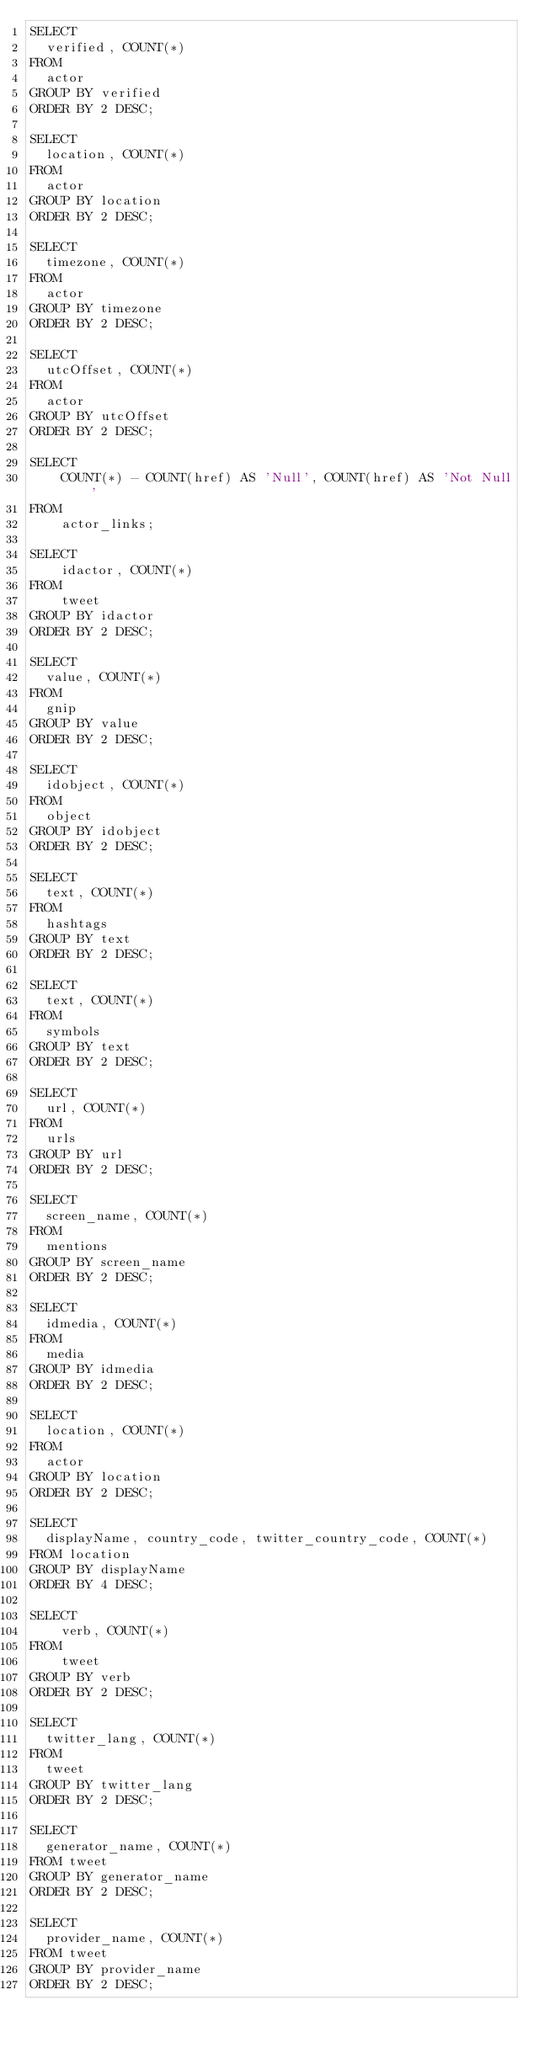<code> <loc_0><loc_0><loc_500><loc_500><_SQL_>SELECT
	verified, COUNT(*)
FROM
	actor
GROUP BY verified
ORDER BY 2 DESC;

SELECT
	location, COUNT(*)
FROM
	actor
GROUP BY location
ORDER BY 2 DESC;

SELECT
	timezone, COUNT(*)
FROM
	actor
GROUP BY timezone
ORDER BY 2 DESC;

SELECT
	utcOffset, COUNT(*)
FROM
	actor
GROUP BY utcOffset
ORDER BY 2 DESC;

SELECT 
    COUNT(*) - COUNT(href) AS 'Null', COUNT(href) AS 'Not Null'
FROM
    actor_links;

SELECT 
    idactor, COUNT(*)
FROM
    tweet
GROUP BY idactor
ORDER BY 2 DESC;

SELECT
	value, COUNT(*)
FROM
	gnip
GROUP BY value
ORDER BY 2 DESC;

SELECT
	idobject, COUNT(*)
FROM
	object
GROUP BY idobject
ORDER BY 2 DESC;

SELECT
	text, COUNT(*)
FROM
	hashtags
GROUP BY text
ORDER BY 2 DESC;

SELECT
	text, COUNT(*)
FROM
	symbols
GROUP BY text
ORDER BY 2 DESC;

SELECT
	url, COUNT(*)
FROM
	urls
GROUP BY url
ORDER BY 2 DESC;

SELECT
	screen_name, COUNT(*)
FROM
	mentions
GROUP BY screen_name
ORDER BY 2 DESC;

SELECT
	idmedia, COUNT(*)
FROM
	media
GROUP BY idmedia
ORDER BY 2 DESC;

SELECT
	location, COUNT(*)
FROM
	actor
GROUP BY location
ORDER BY 2 DESC;

SELECT
	displayName, country_code, twitter_country_code, COUNT(*)
FROM location
GROUP BY displayName
ORDER BY 4 DESC;

SELECT 
    verb, COUNT(*)
FROM
    tweet
GROUP BY verb
ORDER BY 2 DESC;

SELECT
	twitter_lang, COUNT(*)
FROM
	tweet
GROUP BY twitter_lang
ORDER BY 2 DESC;

SELECT
	generator_name, COUNT(*)
FROM tweet
GROUP BY generator_name
ORDER BY 2 DESC;

SELECT
	provider_name, COUNT(*)
FROM tweet
GROUP BY provider_name
ORDER BY 2 DESC;

</code> 